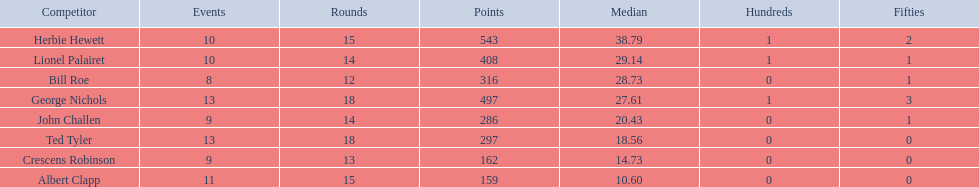Which player had the least amount of runs? Albert Clapp. 